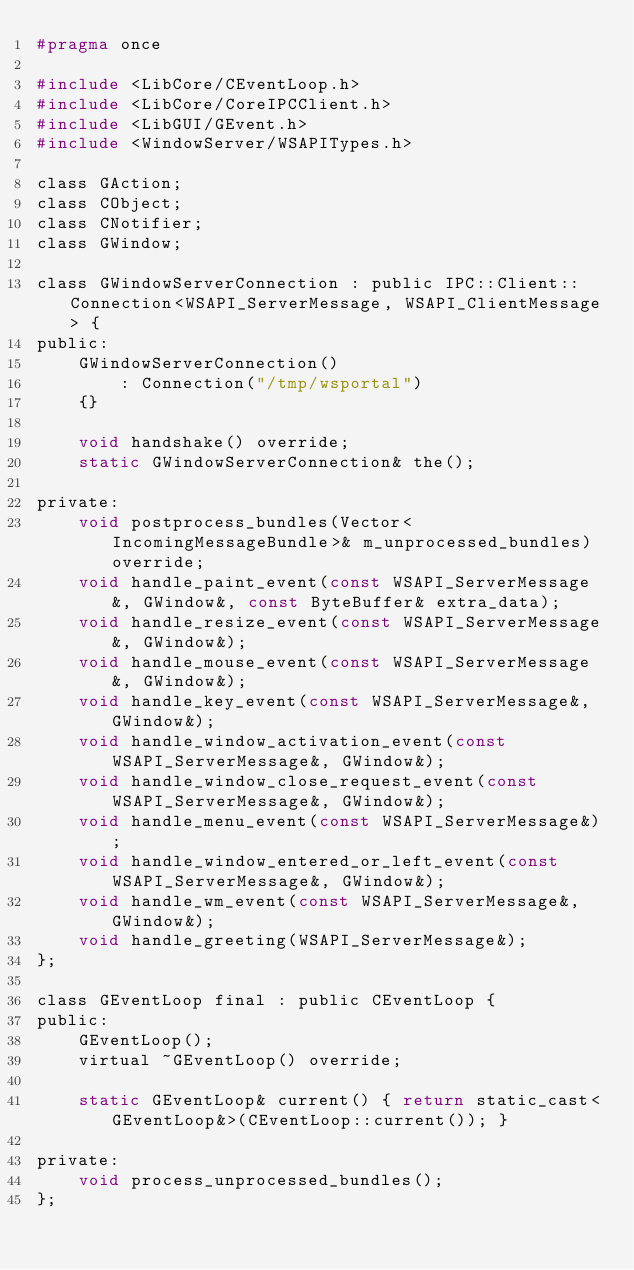Convert code to text. <code><loc_0><loc_0><loc_500><loc_500><_C_>#pragma once

#include <LibCore/CEventLoop.h>
#include <LibCore/CoreIPCClient.h>
#include <LibGUI/GEvent.h>
#include <WindowServer/WSAPITypes.h>

class GAction;
class CObject;
class CNotifier;
class GWindow;

class GWindowServerConnection : public IPC::Client::Connection<WSAPI_ServerMessage, WSAPI_ClientMessage> {
public:
    GWindowServerConnection()
        : Connection("/tmp/wsportal")
    {}

    void handshake() override;
    static GWindowServerConnection& the();

private:
    void postprocess_bundles(Vector<IncomingMessageBundle>& m_unprocessed_bundles) override;
    void handle_paint_event(const WSAPI_ServerMessage&, GWindow&, const ByteBuffer& extra_data);
    void handle_resize_event(const WSAPI_ServerMessage&, GWindow&);
    void handle_mouse_event(const WSAPI_ServerMessage&, GWindow&);
    void handle_key_event(const WSAPI_ServerMessage&, GWindow&);
    void handle_window_activation_event(const WSAPI_ServerMessage&, GWindow&);
    void handle_window_close_request_event(const WSAPI_ServerMessage&, GWindow&);
    void handle_menu_event(const WSAPI_ServerMessage&);
    void handle_window_entered_or_left_event(const WSAPI_ServerMessage&, GWindow&);
    void handle_wm_event(const WSAPI_ServerMessage&, GWindow&);
    void handle_greeting(WSAPI_ServerMessage&);
};

class GEventLoop final : public CEventLoop {
public:
    GEventLoop();
    virtual ~GEventLoop() override;

    static GEventLoop& current() { return static_cast<GEventLoop&>(CEventLoop::current()); }

private:
    void process_unprocessed_bundles();
};
</code> 